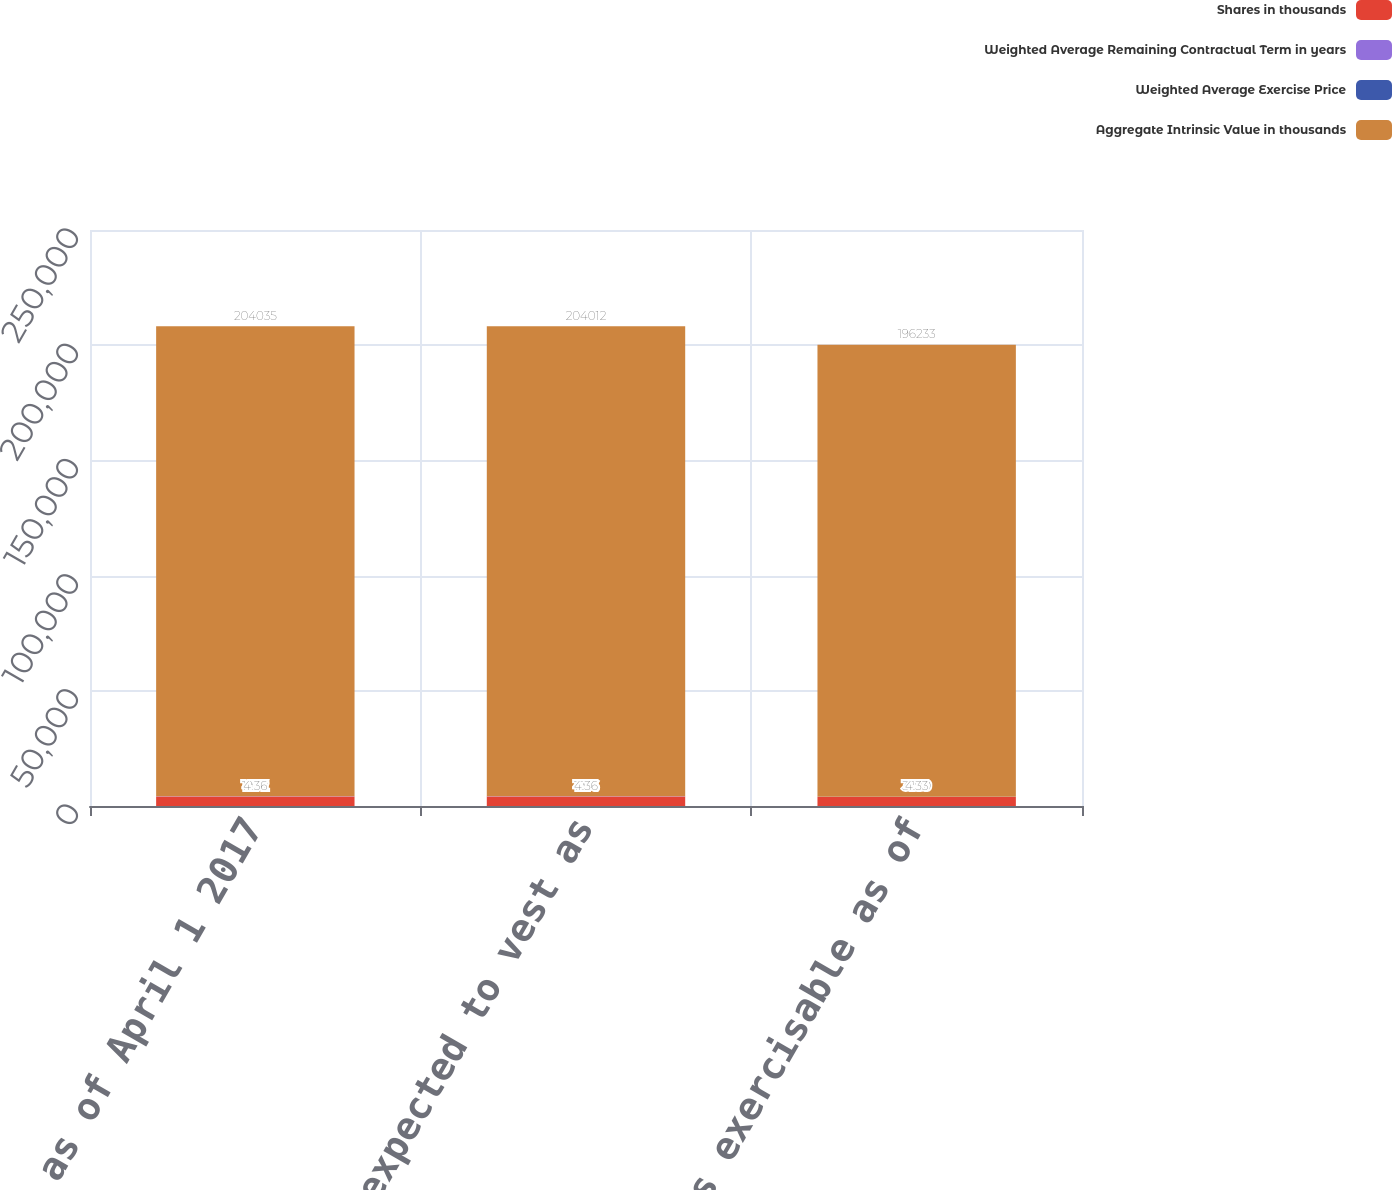<chart> <loc_0><loc_0><loc_500><loc_500><stacked_bar_chart><ecel><fcel>Outstanding as of April 1 2017<fcel>Vested and expected to vest as<fcel>Options exercisable as of<nl><fcel>Shares in thousands<fcel>4177<fcel>4176<fcel>3960<nl><fcel>Weighted Average Remaining Contractual Term in years<fcel>19.72<fcel>19.71<fcel>19<nl><fcel>Weighted Average Exercise Price<fcel>4.36<fcel>4.36<fcel>4.33<nl><fcel>Aggregate Intrinsic Value in thousands<fcel>204035<fcel>204012<fcel>196233<nl></chart> 